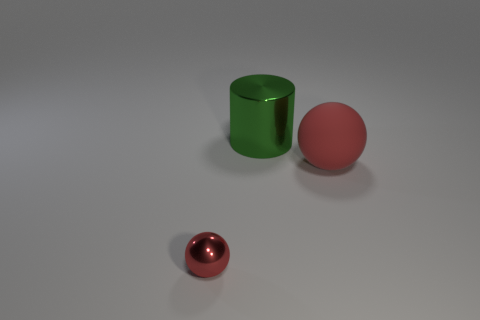The other small object that is the same color as the matte thing is what shape?
Give a very brief answer. Sphere. Are there any metallic things of the same shape as the rubber thing?
Provide a succinct answer. Yes. There is a large rubber ball to the right of the sphere left of the big metallic thing; how many green metallic cylinders are to the left of it?
Keep it short and to the point. 1. There is a tiny object; is it the same color as the rubber sphere that is behind the tiny sphere?
Make the answer very short. Yes. What number of things are either metallic things behind the red metallic object or objects right of the small object?
Provide a succinct answer. 2. Are there more big balls that are behind the tiny ball than green metallic cylinders left of the large cylinder?
Offer a very short reply. Yes. What is the material of the object in front of the sphere that is right of the thing in front of the large matte sphere?
Provide a short and direct response. Metal. Does the metallic object on the right side of the small red shiny thing have the same shape as the metallic thing that is in front of the big matte ball?
Keep it short and to the point. No. Are there any green metallic objects of the same size as the matte sphere?
Offer a very short reply. Yes. What number of red objects are tiny metal balls or shiny cylinders?
Your answer should be compact. 1. 